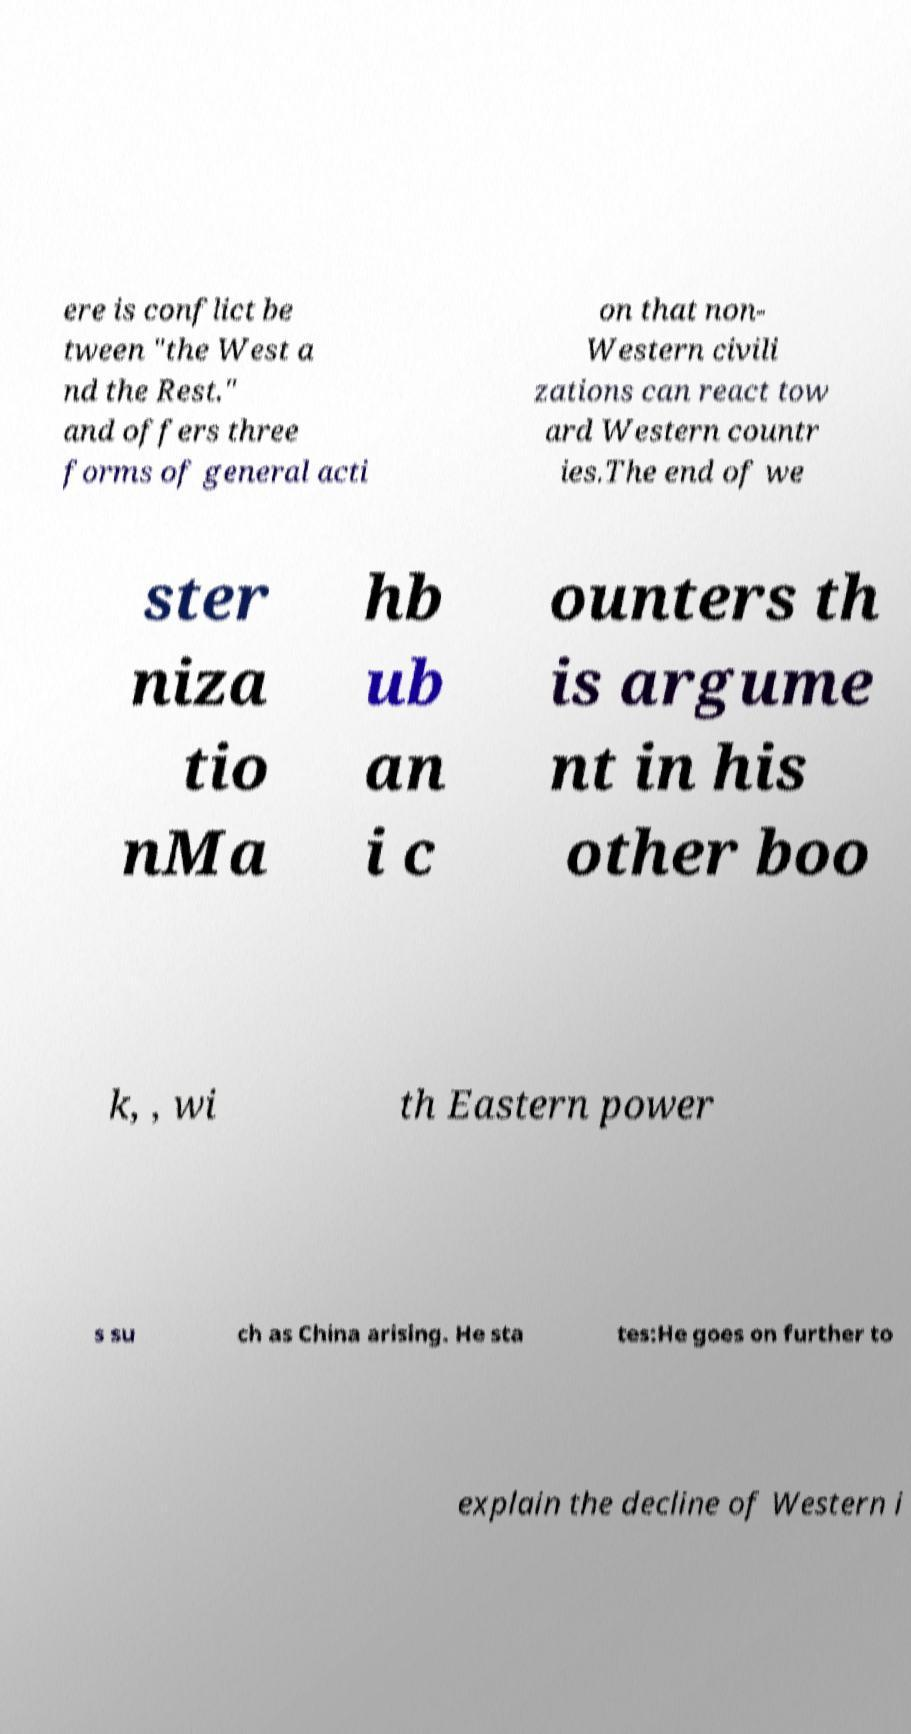Please read and relay the text visible in this image. What does it say? ere is conflict be tween "the West a nd the Rest." and offers three forms of general acti on that non- Western civili zations can react tow ard Western countr ies.The end of we ster niza tio nMa hb ub an i c ounters th is argume nt in his other boo k, , wi th Eastern power s su ch as China arising. He sta tes:He goes on further to explain the decline of Western i 